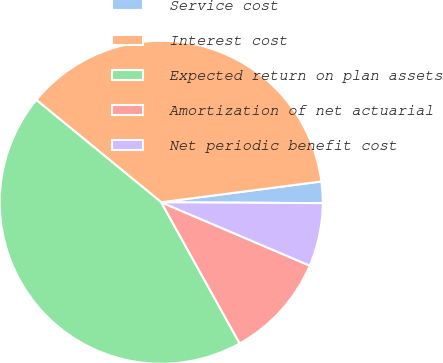<chart> <loc_0><loc_0><loc_500><loc_500><pie_chart><fcel>Service cost<fcel>Interest cost<fcel>Expected return on plan assets<fcel>Amortization of net actuarial<fcel>Net periodic benefit cost<nl><fcel>2.14%<fcel>37.02%<fcel>44.0%<fcel>10.51%<fcel>6.33%<nl></chart> 